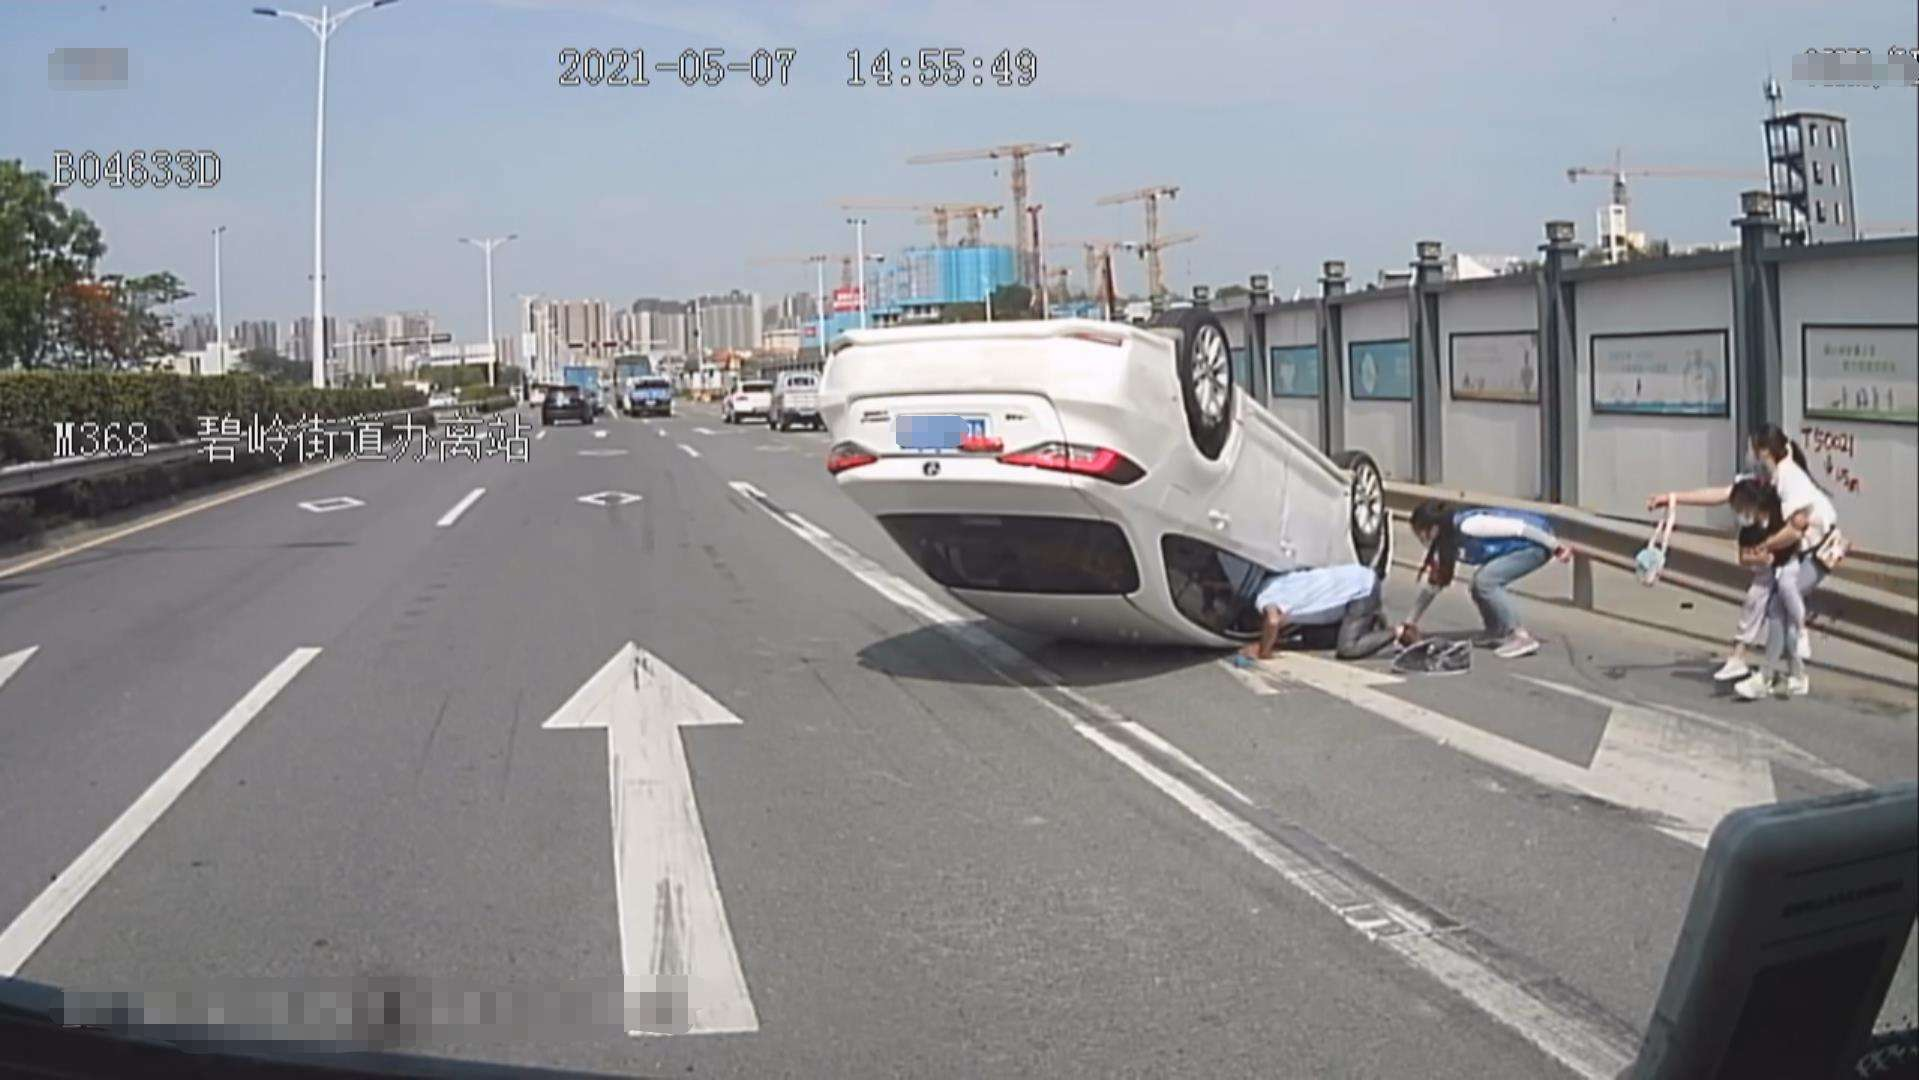Can you tell me about the safety aspects visible in the image? From the image, it's observed that the accident happened in a lane with an arrow indicating a straight path, which means that any deviation from the path might have contributed to the accident. One can also notice that some safety measures are being taken, as people are assisting the situation while being careful of the surrounding traffic. However, there's a lack of emergency services at the scene, which can be crucial for safety and accident response. 